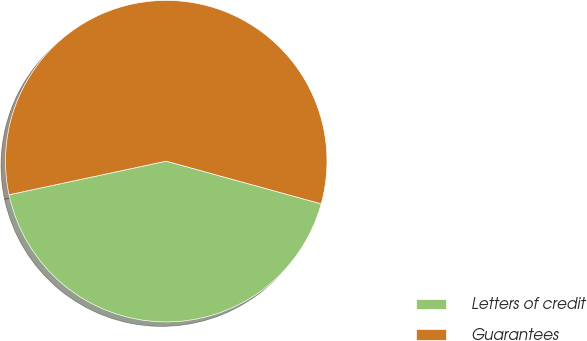<chart> <loc_0><loc_0><loc_500><loc_500><pie_chart><fcel>Letters of credit<fcel>Guarantees<nl><fcel>42.37%<fcel>57.63%<nl></chart> 